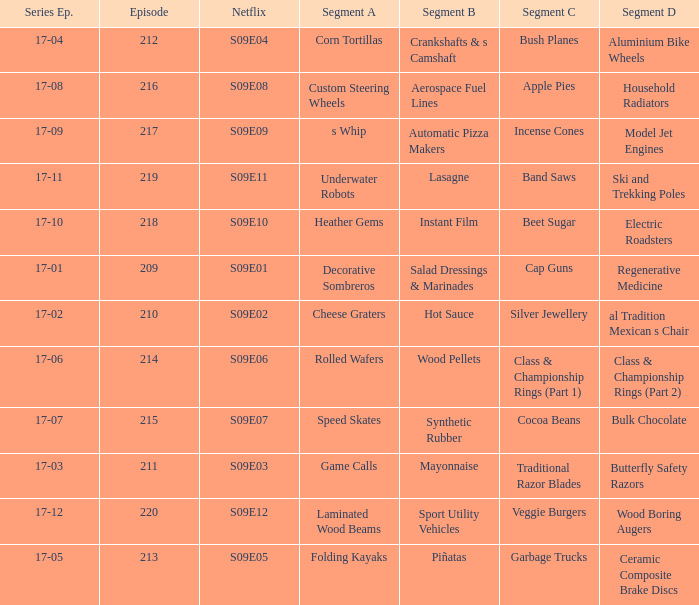For the shows featuring beet sugar, what was on before that Instant Film. 